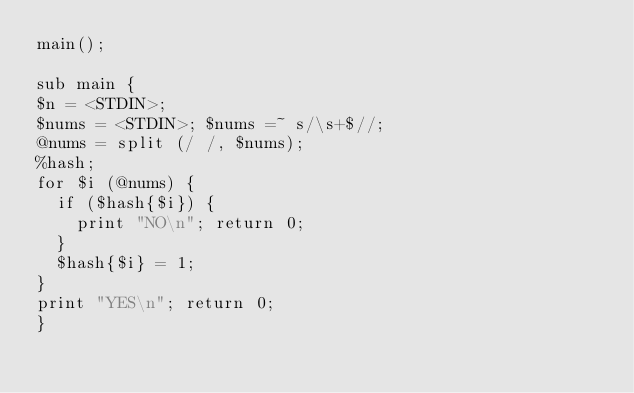Convert code to text. <code><loc_0><loc_0><loc_500><loc_500><_Perl_>main();

sub main {
$n = <STDIN>;
$nums = <STDIN>; $nums =~ s/\s+$//;
@nums = split (/ /, $nums);
%hash;
for $i (@nums) {
  if ($hash{$i}) {
    print "NO\n"; return 0;
  }
  $hash{$i} = 1;
}
print "YES\n"; return 0;
}
</code> 